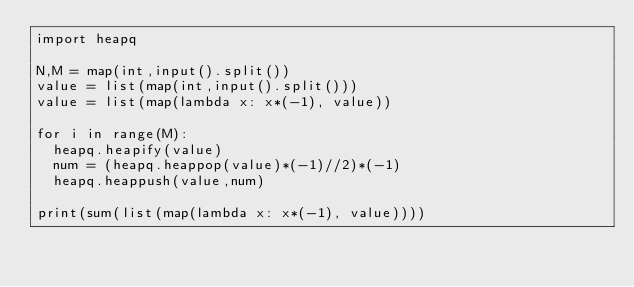Convert code to text. <code><loc_0><loc_0><loc_500><loc_500><_Python_>import heapq

N,M = map(int,input().split())
value = list(map(int,input().split()))
value = list(map(lambda x: x*(-1), value))

for i in range(M):
  heapq.heapify(value)
  num = (heapq.heappop(value)*(-1)//2)*(-1)
  heapq.heappush(value,num)

print(sum(list(map(lambda x: x*(-1), value))))</code> 